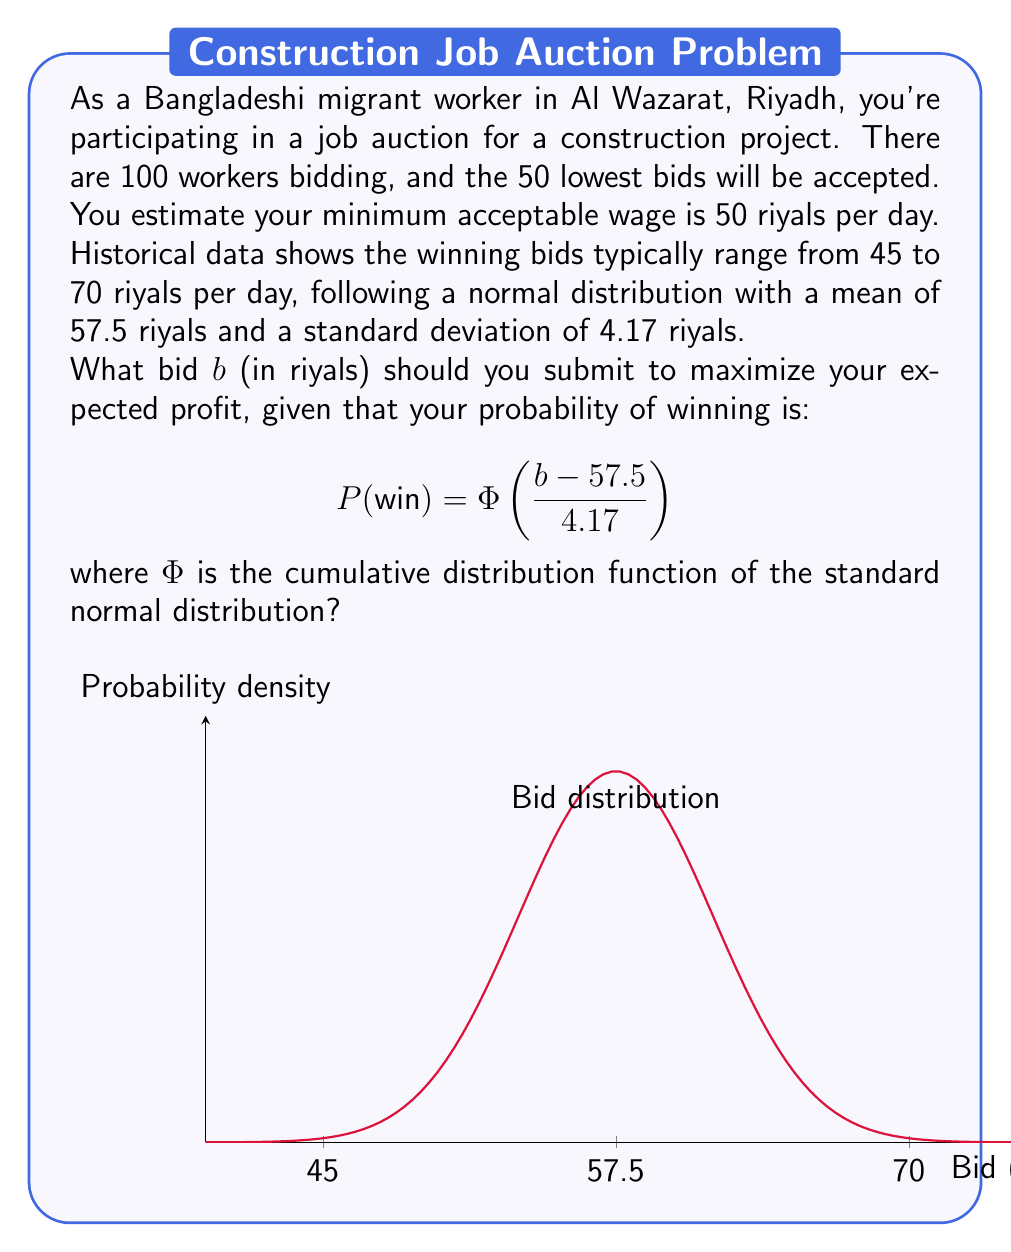Teach me how to tackle this problem. Let's approach this step-by-step:

1) The expected profit is the product of the probability of winning and the profit if you win:

   $$E(\text{profit}) = P(\text{win}) \cdot (b - 50)$$

2) Substituting the given probability function:

   $$E(\text{profit}) = \Phi\left(\frac{b - 57.5}{4.17}\right) \cdot (b - 50)$$

3) To maximize this, we need to find the value of $b$ where the derivative of this function equals zero:

   $$\frac{d}{db}E(\text{profit}) = \phi\left(\frac{b - 57.5}{4.17}\right) \cdot \frac{1}{4.17} \cdot (b - 50) + \Phi\left(\frac{b - 57.5}{4.17}\right) = 0$$

   where $\phi$ is the probability density function of the standard normal distribution.

4) This equation doesn't have a closed-form solution, so we need to solve it numerically.

5) Using numerical methods (e.g., Newton-Raphson method), we find that the equation is satisfied when $b \approx 58.33$.

6) We can verify that this is indeed a maximum by checking the second derivative is negative at this point.

Therefore, the optimal bidding strategy is to bid approximately 58.33 riyals per day.
Answer: $58.33$ riyals 